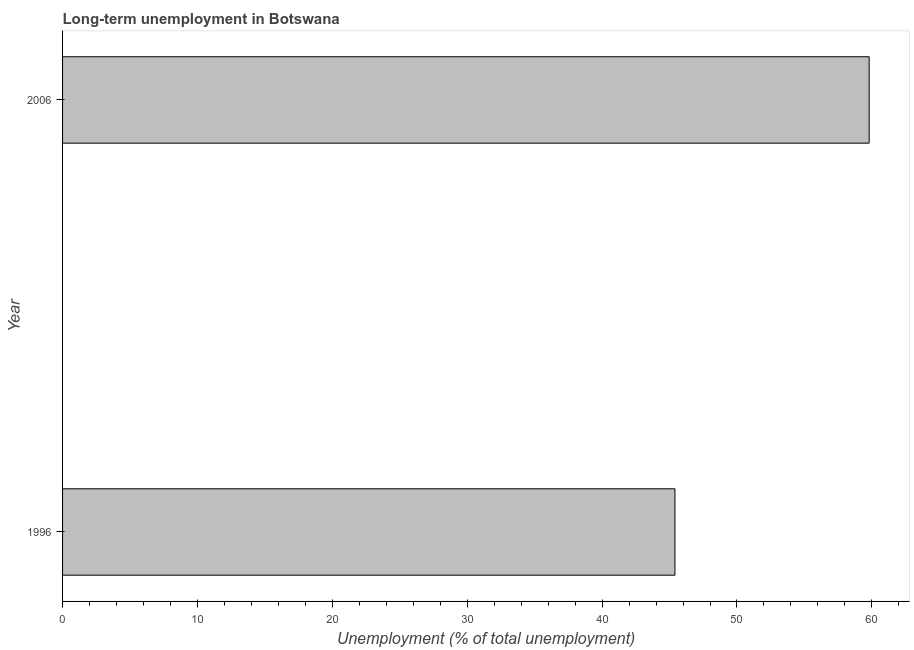Does the graph contain any zero values?
Keep it short and to the point. No. What is the title of the graph?
Provide a short and direct response. Long-term unemployment in Botswana. What is the label or title of the X-axis?
Provide a short and direct response. Unemployment (% of total unemployment). What is the long-term unemployment in 2006?
Your answer should be compact. 59.8. Across all years, what is the maximum long-term unemployment?
Provide a succinct answer. 59.8. Across all years, what is the minimum long-term unemployment?
Your answer should be compact. 45.4. In which year was the long-term unemployment maximum?
Give a very brief answer. 2006. What is the sum of the long-term unemployment?
Make the answer very short. 105.2. What is the difference between the long-term unemployment in 1996 and 2006?
Your response must be concise. -14.4. What is the average long-term unemployment per year?
Offer a very short reply. 52.6. What is the median long-term unemployment?
Offer a terse response. 52.6. Do a majority of the years between 2006 and 1996 (inclusive) have long-term unemployment greater than 4 %?
Make the answer very short. No. What is the ratio of the long-term unemployment in 1996 to that in 2006?
Keep it short and to the point. 0.76. How many bars are there?
Provide a short and direct response. 2. Are all the bars in the graph horizontal?
Offer a terse response. Yes. How many years are there in the graph?
Ensure brevity in your answer.  2. Are the values on the major ticks of X-axis written in scientific E-notation?
Keep it short and to the point. No. What is the Unemployment (% of total unemployment) in 1996?
Make the answer very short. 45.4. What is the Unemployment (% of total unemployment) in 2006?
Your answer should be compact. 59.8. What is the difference between the Unemployment (% of total unemployment) in 1996 and 2006?
Your answer should be very brief. -14.4. What is the ratio of the Unemployment (% of total unemployment) in 1996 to that in 2006?
Give a very brief answer. 0.76. 